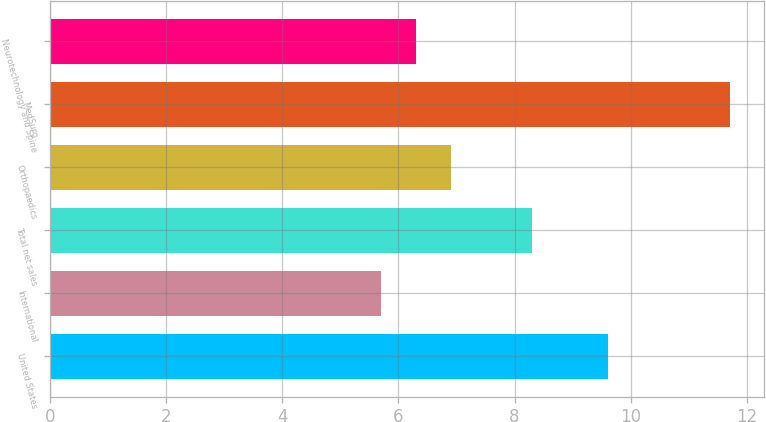<chart> <loc_0><loc_0><loc_500><loc_500><bar_chart><fcel>United States<fcel>International<fcel>Total net sales<fcel>Orthopaedics<fcel>MedSurg<fcel>Neurotechnology and Spine<nl><fcel>9.6<fcel>5.7<fcel>8.3<fcel>6.9<fcel>11.7<fcel>6.3<nl></chart> 